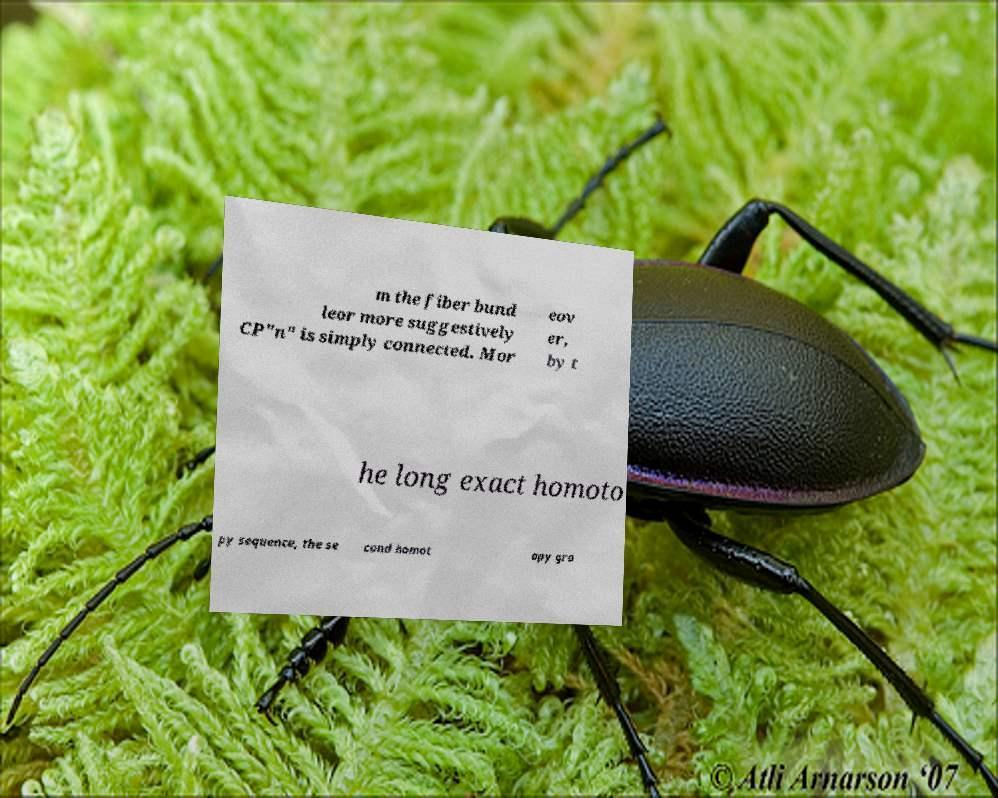I need the written content from this picture converted into text. Can you do that? m the fiber bund leor more suggestively CP"n" is simply connected. Mor eov er, by t he long exact homoto py sequence, the se cond homot opy gro 